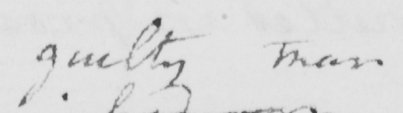What text is written in this handwritten line? guilty man 